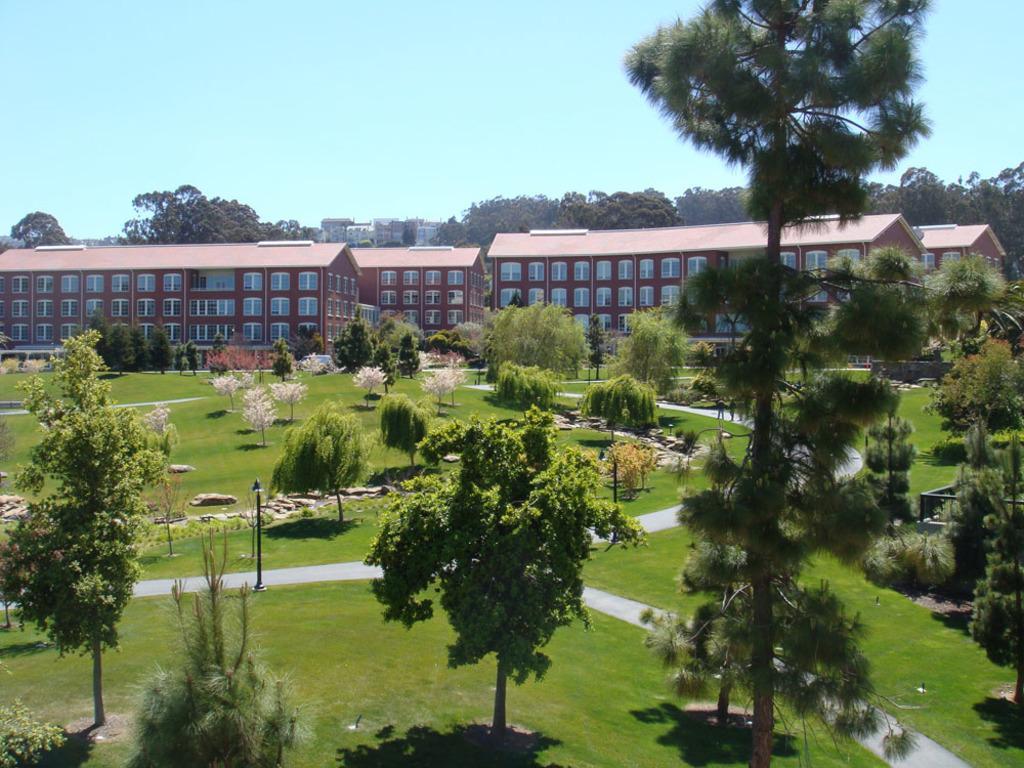Describe this image in one or two sentences. In this image at the bottom, there are trees, plants, stones, grass. In the middle there are buildings, trees, windows and sky. 